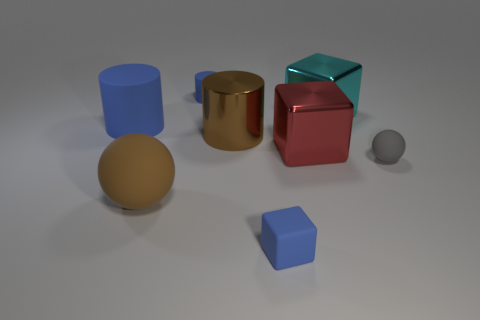There is a blue thing that is the same shape as the red thing; what is its size?
Offer a very short reply. Small. Is there anything else that is the same size as the cyan object?
Your response must be concise. Yes. What is the material of the large cylinder to the right of the blue rubber cylinder that is left of the blue rubber cylinder that is behind the large blue rubber thing?
Your answer should be very brief. Metal. Are there more big cyan shiny cubes that are left of the red metallic thing than blue blocks behind the large sphere?
Ensure brevity in your answer.  No. Do the gray ball and the cyan shiny block have the same size?
Make the answer very short. No. What color is the other matte thing that is the same shape as the big red object?
Give a very brief answer. Blue. What number of small matte spheres have the same color as the metal cylinder?
Provide a short and direct response. 0. Is the number of big brown metallic objects right of the large brown cylinder greater than the number of tiny cyan rubber blocks?
Offer a terse response. No. The sphere that is behind the brown thing that is in front of the gray rubber ball is what color?
Your answer should be very brief. Gray. What number of things are either balls that are to the left of the small gray matte sphere or big things that are right of the brown matte ball?
Provide a succinct answer. 4. 